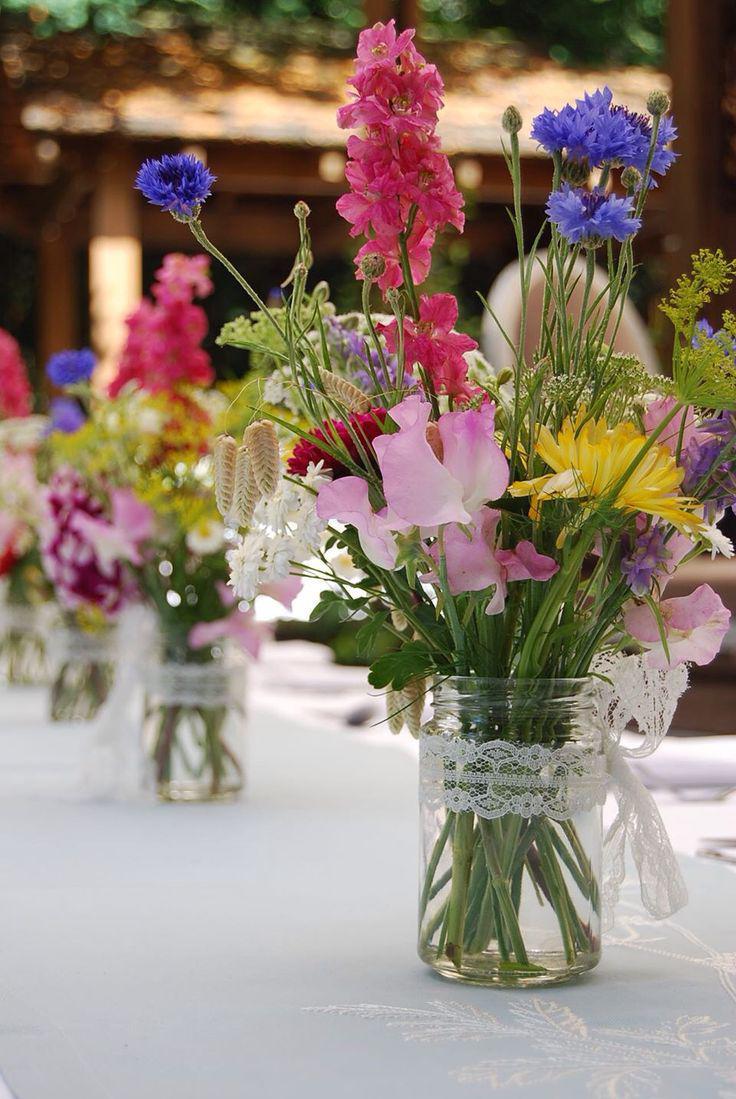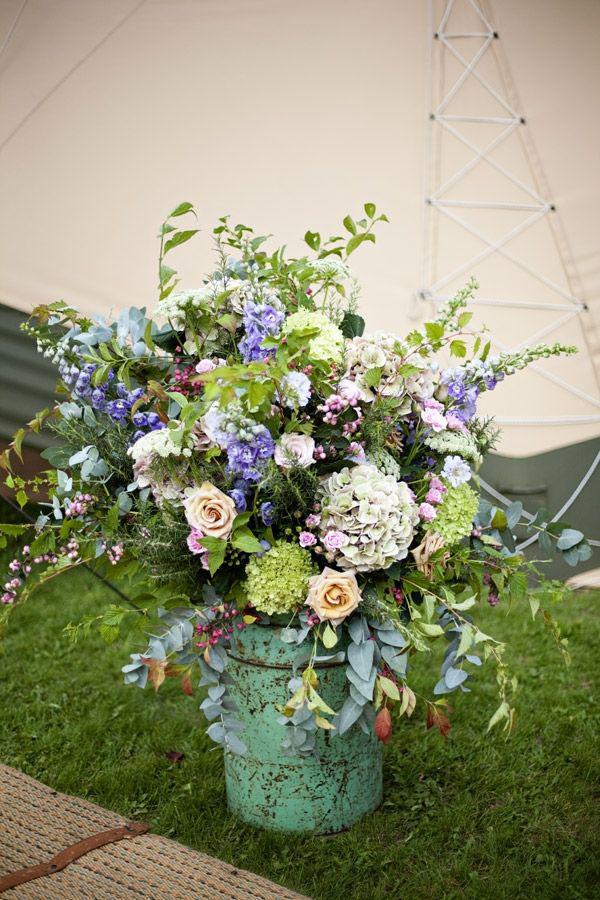The first image is the image on the left, the second image is the image on the right. Analyze the images presented: Is the assertion "In one of the images there is at least one bouquet in a clear glass vase." valid? Answer yes or no. Yes. The first image is the image on the left, the second image is the image on the right. Evaluate the accuracy of this statement regarding the images: "One image features a single floral arrangement, which includes long stems with yellow flowers in an opaque container with at least one handle.". Is it true? Answer yes or no. No. 